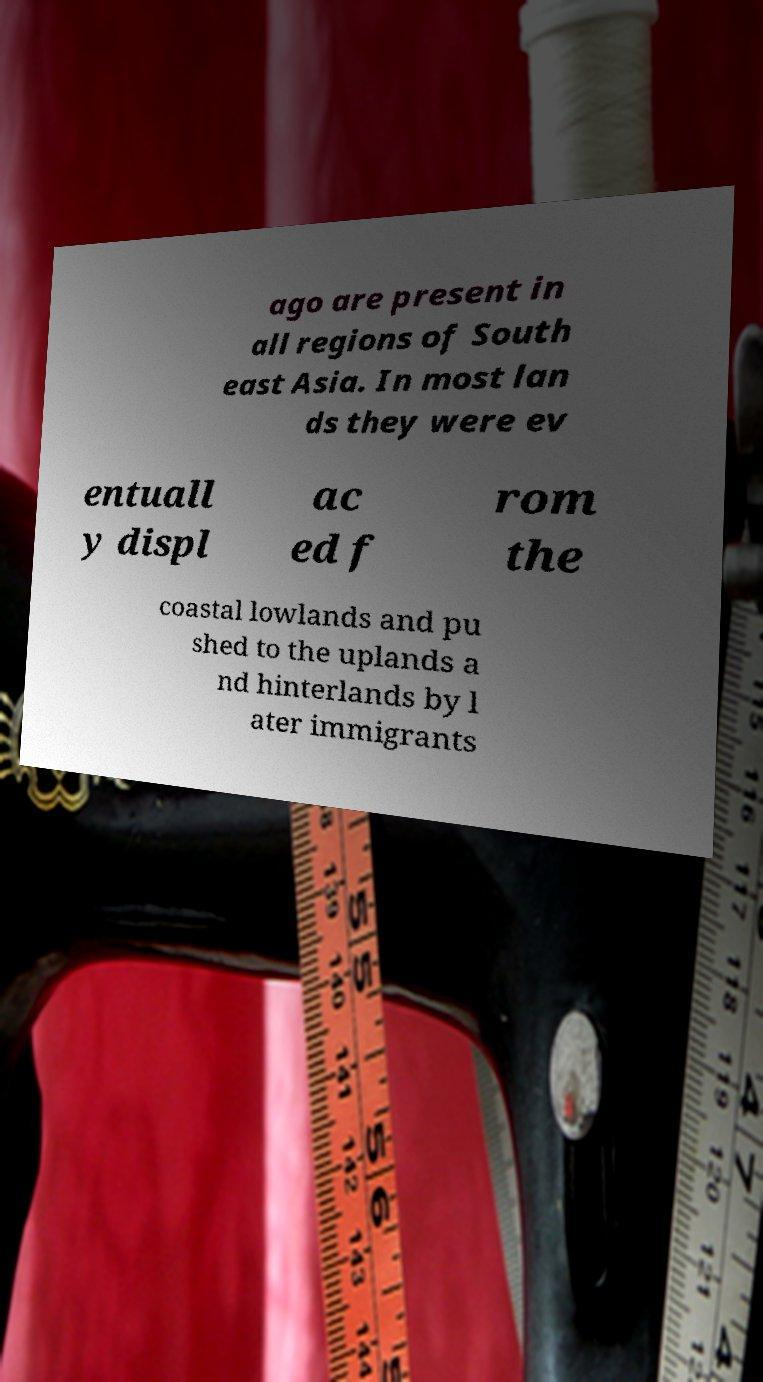For documentation purposes, I need the text within this image transcribed. Could you provide that? ago are present in all regions of South east Asia. In most lan ds they were ev entuall y displ ac ed f rom the coastal lowlands and pu shed to the uplands a nd hinterlands by l ater immigrants 